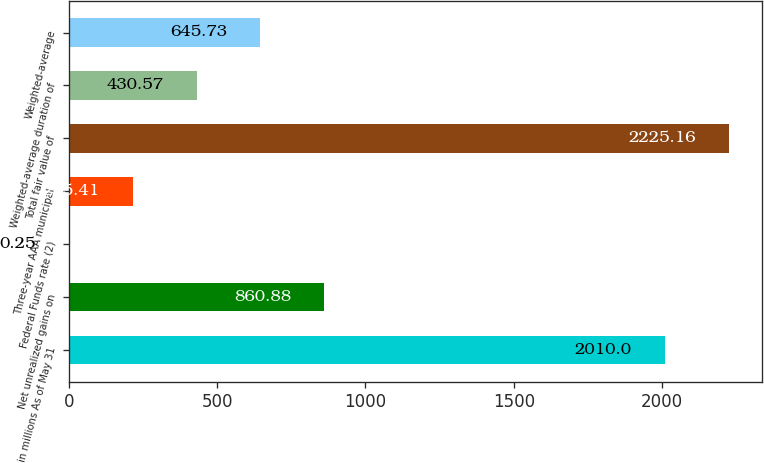Convert chart to OTSL. <chart><loc_0><loc_0><loc_500><loc_500><bar_chart><fcel>in millions As of May 31<fcel>Net unrealized gains on<fcel>Federal Funds rate (2)<fcel>Three-year AAA municipal<fcel>Total fair value of<fcel>Weighted-average duration of<fcel>Weighted-average<nl><fcel>2010<fcel>860.88<fcel>0.25<fcel>215.41<fcel>2225.16<fcel>430.57<fcel>645.73<nl></chart> 